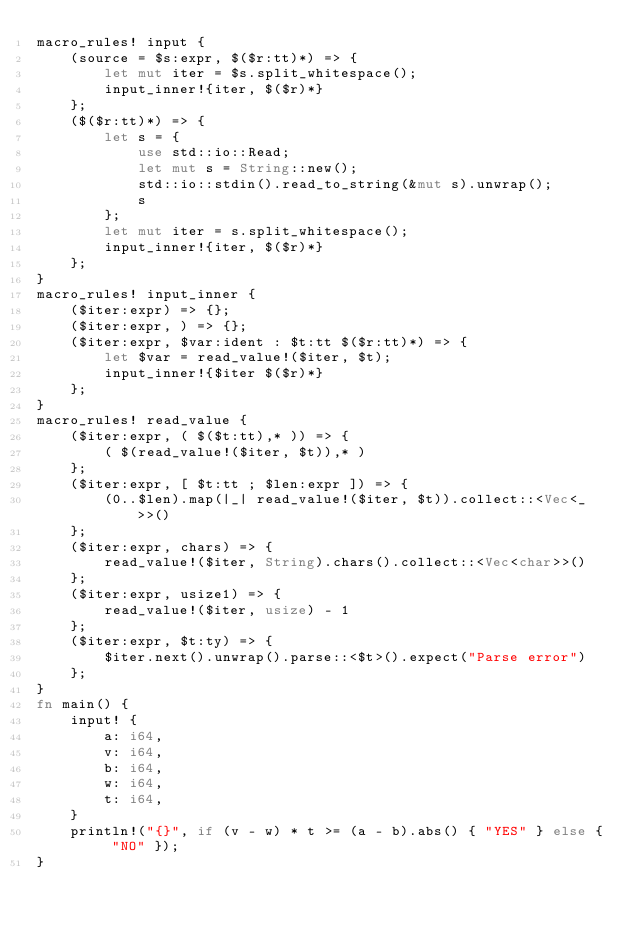Convert code to text. <code><loc_0><loc_0><loc_500><loc_500><_Rust_>macro_rules! input {
    (source = $s:expr, $($r:tt)*) => {
        let mut iter = $s.split_whitespace();
        input_inner!{iter, $($r)*}
    };
    ($($r:tt)*) => {
        let s = {
            use std::io::Read;
            let mut s = String::new();
            std::io::stdin().read_to_string(&mut s).unwrap();
            s
        };
        let mut iter = s.split_whitespace();
        input_inner!{iter, $($r)*}
    };
}
macro_rules! input_inner {
    ($iter:expr) => {};
    ($iter:expr, ) => {};
    ($iter:expr, $var:ident : $t:tt $($r:tt)*) => {
        let $var = read_value!($iter, $t);
        input_inner!{$iter $($r)*}
    };
}
macro_rules! read_value {
    ($iter:expr, ( $($t:tt),* )) => {
        ( $(read_value!($iter, $t)),* )
    };
    ($iter:expr, [ $t:tt ; $len:expr ]) => {
        (0..$len).map(|_| read_value!($iter, $t)).collect::<Vec<_>>()
    };
    ($iter:expr, chars) => {
        read_value!($iter, String).chars().collect::<Vec<char>>()
    };
    ($iter:expr, usize1) => {
        read_value!($iter, usize) - 1
    };
    ($iter:expr, $t:ty) => {
        $iter.next().unwrap().parse::<$t>().expect("Parse error")
    };
}
fn main() {
    input! {
        a: i64,
        v: i64,
        b: i64,
        w: i64,
        t: i64,
    }
    println!("{}", if (v - w) * t >= (a - b).abs() { "YES" } else { "NO" });
}</code> 